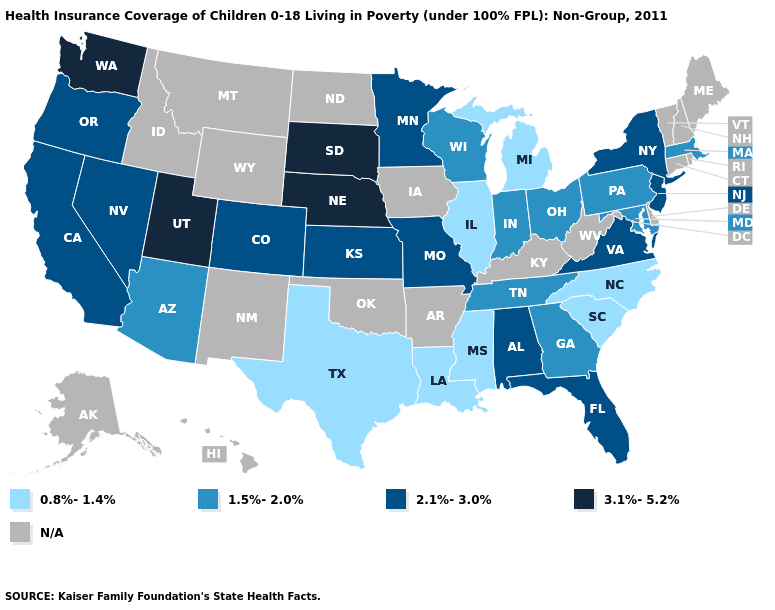Which states have the lowest value in the South?
Give a very brief answer. Louisiana, Mississippi, North Carolina, South Carolina, Texas. Name the states that have a value in the range 1.5%-2.0%?
Write a very short answer. Arizona, Georgia, Indiana, Maryland, Massachusetts, Ohio, Pennsylvania, Tennessee, Wisconsin. Name the states that have a value in the range 2.1%-3.0%?
Short answer required. Alabama, California, Colorado, Florida, Kansas, Minnesota, Missouri, Nevada, New Jersey, New York, Oregon, Virginia. How many symbols are there in the legend?
Answer briefly. 5. Which states have the highest value in the USA?
Answer briefly. Nebraska, South Dakota, Utah, Washington. Does the first symbol in the legend represent the smallest category?
Keep it brief. Yes. What is the value of Massachusetts?
Answer briefly. 1.5%-2.0%. Name the states that have a value in the range N/A?
Keep it brief. Alaska, Arkansas, Connecticut, Delaware, Hawaii, Idaho, Iowa, Kentucky, Maine, Montana, New Hampshire, New Mexico, North Dakota, Oklahoma, Rhode Island, Vermont, West Virginia, Wyoming. Name the states that have a value in the range N/A?
Be succinct. Alaska, Arkansas, Connecticut, Delaware, Hawaii, Idaho, Iowa, Kentucky, Maine, Montana, New Hampshire, New Mexico, North Dakota, Oklahoma, Rhode Island, Vermont, West Virginia, Wyoming. Does Utah have the highest value in the West?
Be succinct. Yes. How many symbols are there in the legend?
Concise answer only. 5. What is the lowest value in states that border Kansas?
Concise answer only. 2.1%-3.0%. What is the value of Alaska?
Quick response, please. N/A. What is the value of Minnesota?
Quick response, please. 2.1%-3.0%. 